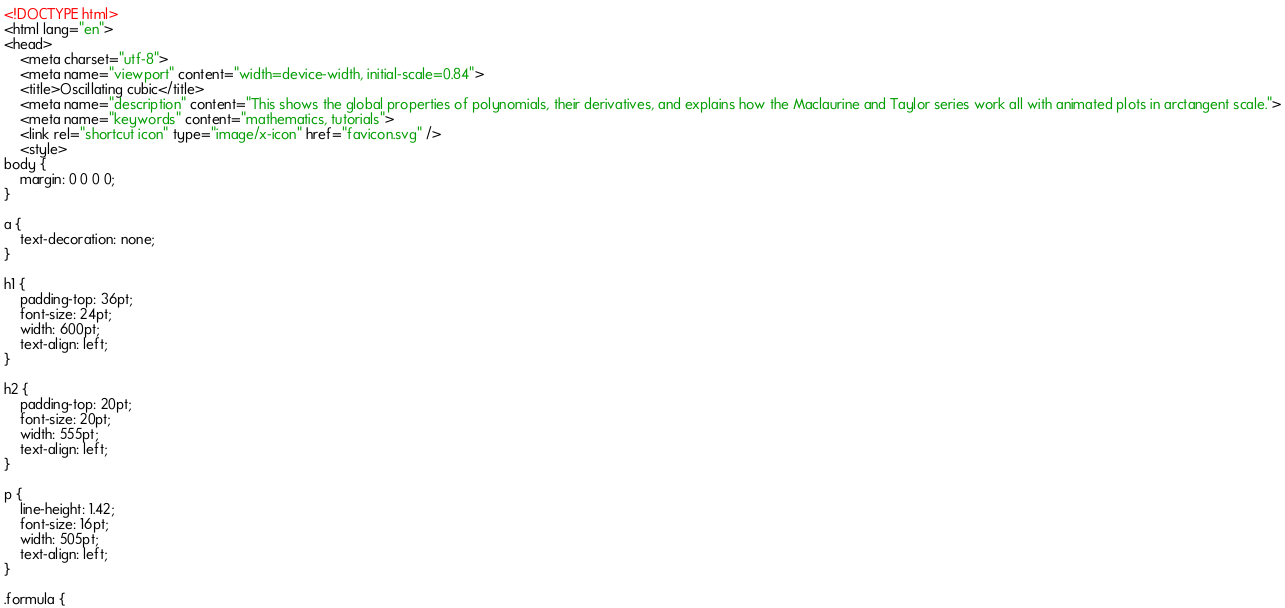<code> <loc_0><loc_0><loc_500><loc_500><_HTML_><!DOCTYPE html>
<html lang="en">
<head>
	<meta charset="utf-8">
	<meta name="viewport" content="width=device-width, initial-scale=0.84">
	<title>Oscillating cubic</title>
	<meta name="description" content="This shows the global properties of polynomials, their derivatives, and explains how the Maclaurine and Taylor series work all with animated plots in arctangent scale.">
	<meta name="keywords" content="mathematics, tutorials">
	<link rel="shortcut icon" type="image/x-icon" href="favicon.svg" />
	<style>
body {
	margin: 0 0 0 0;
}

a {
	text-decoration: none;
}

h1 {
	padding-top: 36pt;
	font-size: 24pt;
	width: 600pt;
	text-align: left;
}

h2 {
	padding-top: 20pt;
	font-size: 20pt;
	width: 555pt;
	text-align: left;
}

p {
	line-height: 1.42;
	font-size: 16pt;
	width: 505pt;
	text-align: left;
}

.formula {</code> 